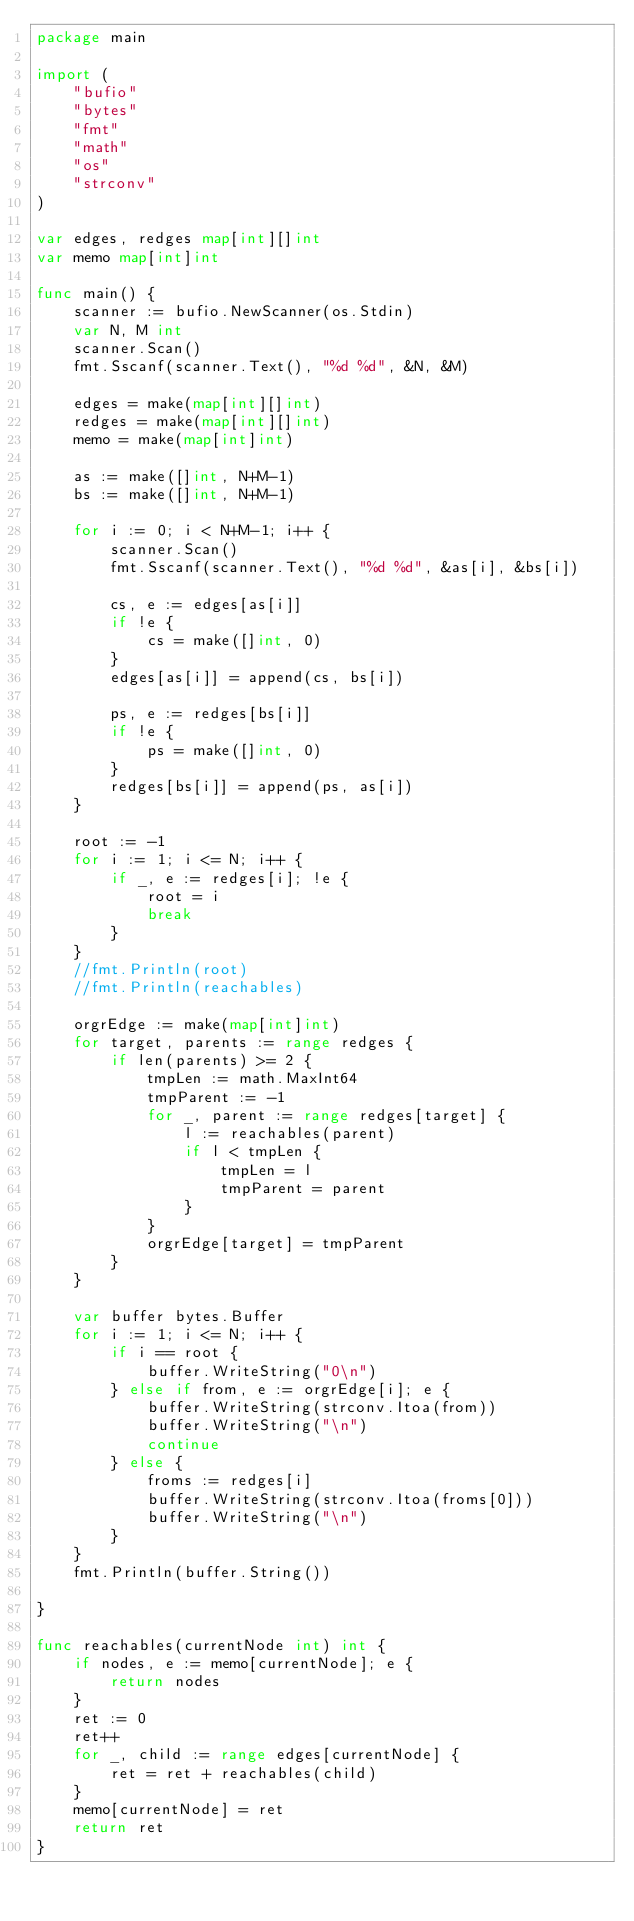<code> <loc_0><loc_0><loc_500><loc_500><_Go_>package main

import (
	"bufio"
	"bytes"
	"fmt"
	"math"
	"os"
	"strconv"
)

var edges, redges map[int][]int
var memo map[int]int

func main() {
	scanner := bufio.NewScanner(os.Stdin)
	var N, M int
	scanner.Scan()
	fmt.Sscanf(scanner.Text(), "%d %d", &N, &M)

	edges = make(map[int][]int)
	redges = make(map[int][]int)
	memo = make(map[int]int)

	as := make([]int, N+M-1)
	bs := make([]int, N+M-1)

	for i := 0; i < N+M-1; i++ {
		scanner.Scan()
		fmt.Sscanf(scanner.Text(), "%d %d", &as[i], &bs[i])

		cs, e := edges[as[i]]
		if !e {
			cs = make([]int, 0)
		}
		edges[as[i]] = append(cs, bs[i])

		ps, e := redges[bs[i]]
		if !e {
			ps = make([]int, 0)
		}
		redges[bs[i]] = append(ps, as[i])
	}

	root := -1
	for i := 1; i <= N; i++ {
		if _, e := redges[i]; !e {
			root = i
			break
		}
	}
	//fmt.Println(root)
	//fmt.Println(reachables)

	orgrEdge := make(map[int]int)
	for target, parents := range redges {
		if len(parents) >= 2 {
			tmpLen := math.MaxInt64
			tmpParent := -1
			for _, parent := range redges[target] {
				l := reachables(parent)
				if l < tmpLen {
					tmpLen = l
					tmpParent = parent
				}
			}
			orgrEdge[target] = tmpParent
		}
	}

	var buffer bytes.Buffer
	for i := 1; i <= N; i++ {
		if i == root {
			buffer.WriteString("0\n")
		} else if from, e := orgrEdge[i]; e {
			buffer.WriteString(strconv.Itoa(from))
			buffer.WriteString("\n")
			continue
		} else {
			froms := redges[i]
			buffer.WriteString(strconv.Itoa(froms[0]))
			buffer.WriteString("\n")
		}
	}
	fmt.Println(buffer.String())

}

func reachables(currentNode int) int {
	if nodes, e := memo[currentNode]; e {
		return nodes
	}
	ret := 0
	ret++
	for _, child := range edges[currentNode] {
		ret = ret + reachables(child)
	}
	memo[currentNode] = ret
	return ret
}
</code> 